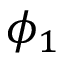<formula> <loc_0><loc_0><loc_500><loc_500>\phi _ { 1 }</formula> 